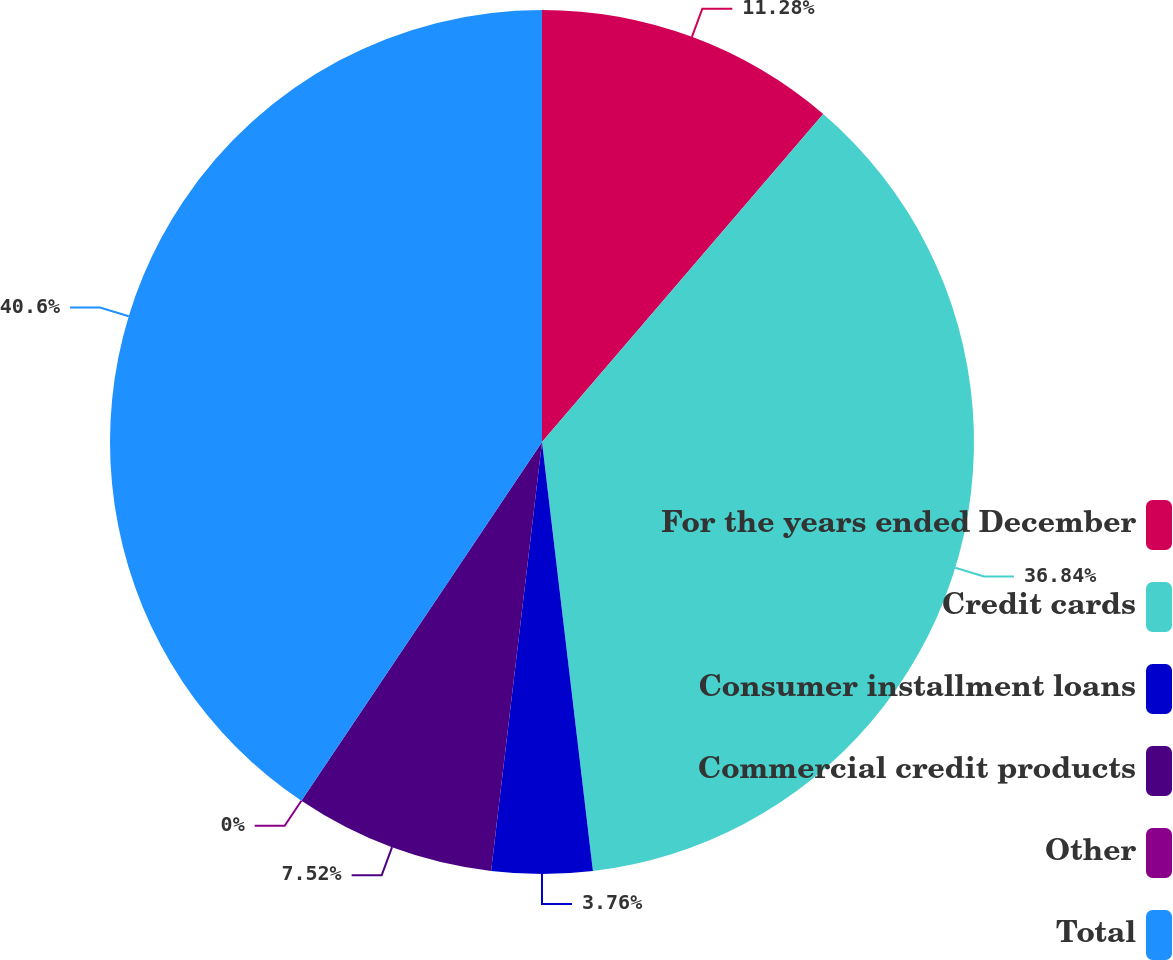Convert chart. <chart><loc_0><loc_0><loc_500><loc_500><pie_chart><fcel>For the years ended December<fcel>Credit cards<fcel>Consumer installment loans<fcel>Commercial credit products<fcel>Other<fcel>Total<nl><fcel>11.28%<fcel>36.83%<fcel>3.76%<fcel>7.52%<fcel>0.0%<fcel>40.59%<nl></chart> 